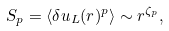<formula> <loc_0><loc_0><loc_500><loc_500>S _ { p } = \langle \delta u _ { L } ( r ) ^ { p } \rangle \sim r ^ { \zeta _ { p } } ,</formula> 